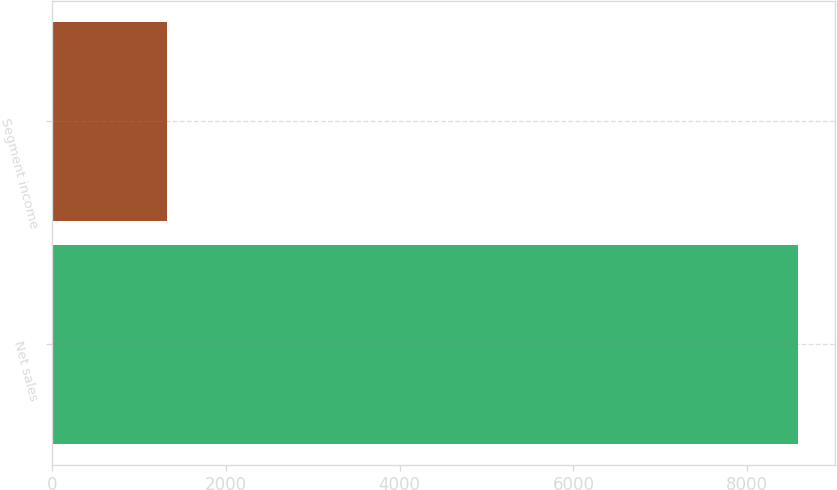<chart> <loc_0><loc_0><loc_500><loc_500><bar_chart><fcel>Net sales<fcel>Segment income<nl><fcel>8580<fcel>1322<nl></chart> 